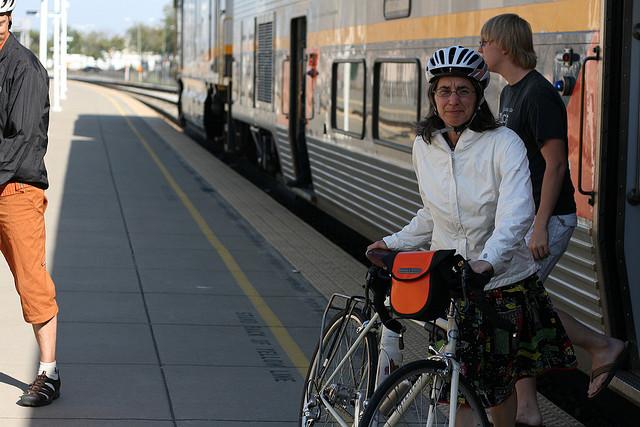Is the sidewalk well maintained?
Be succinct. Yes. What is the yellow painted line for?
Give a very brief answer. Safety. How many people are holding onto a bike in this image?
Short answer required. 1. Is her hair dyed?
Keep it brief. No. Is the woman walking the dog?
Quick response, please. No. What safety protocol is the woman following?
Write a very short answer. Helmet. 